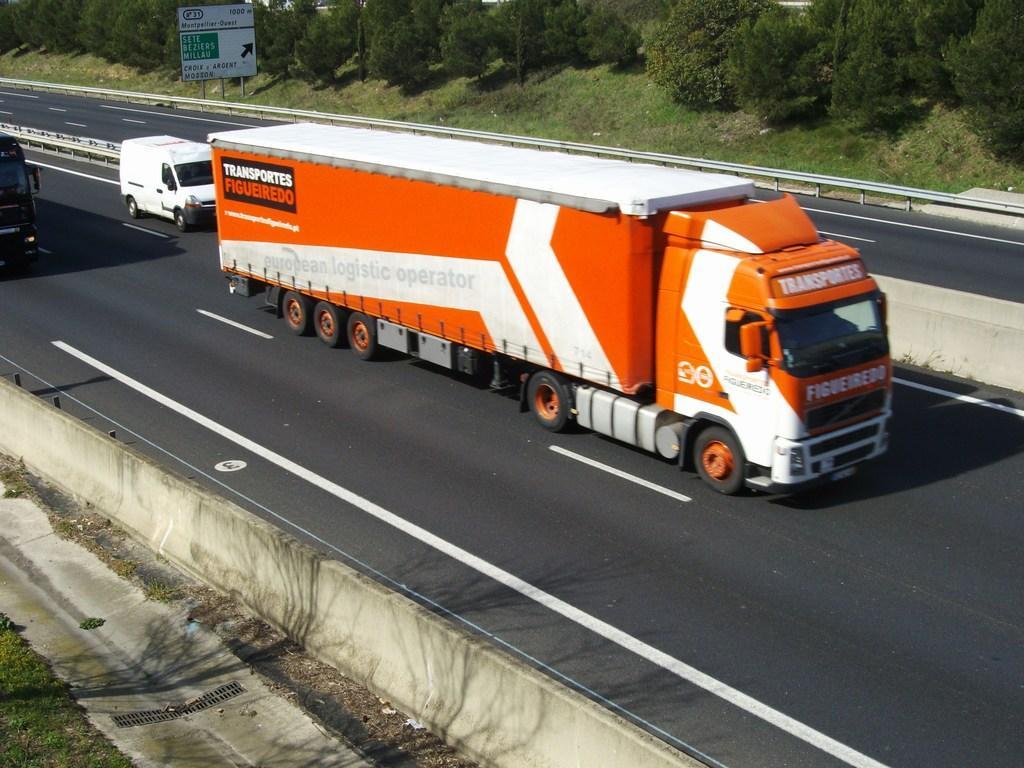Can you describe this image briefly? Here I can see few vehicles on the road which are going towards the right side. On both sides of the road I can see the grass. On the top of the image there are some trees and a board. 